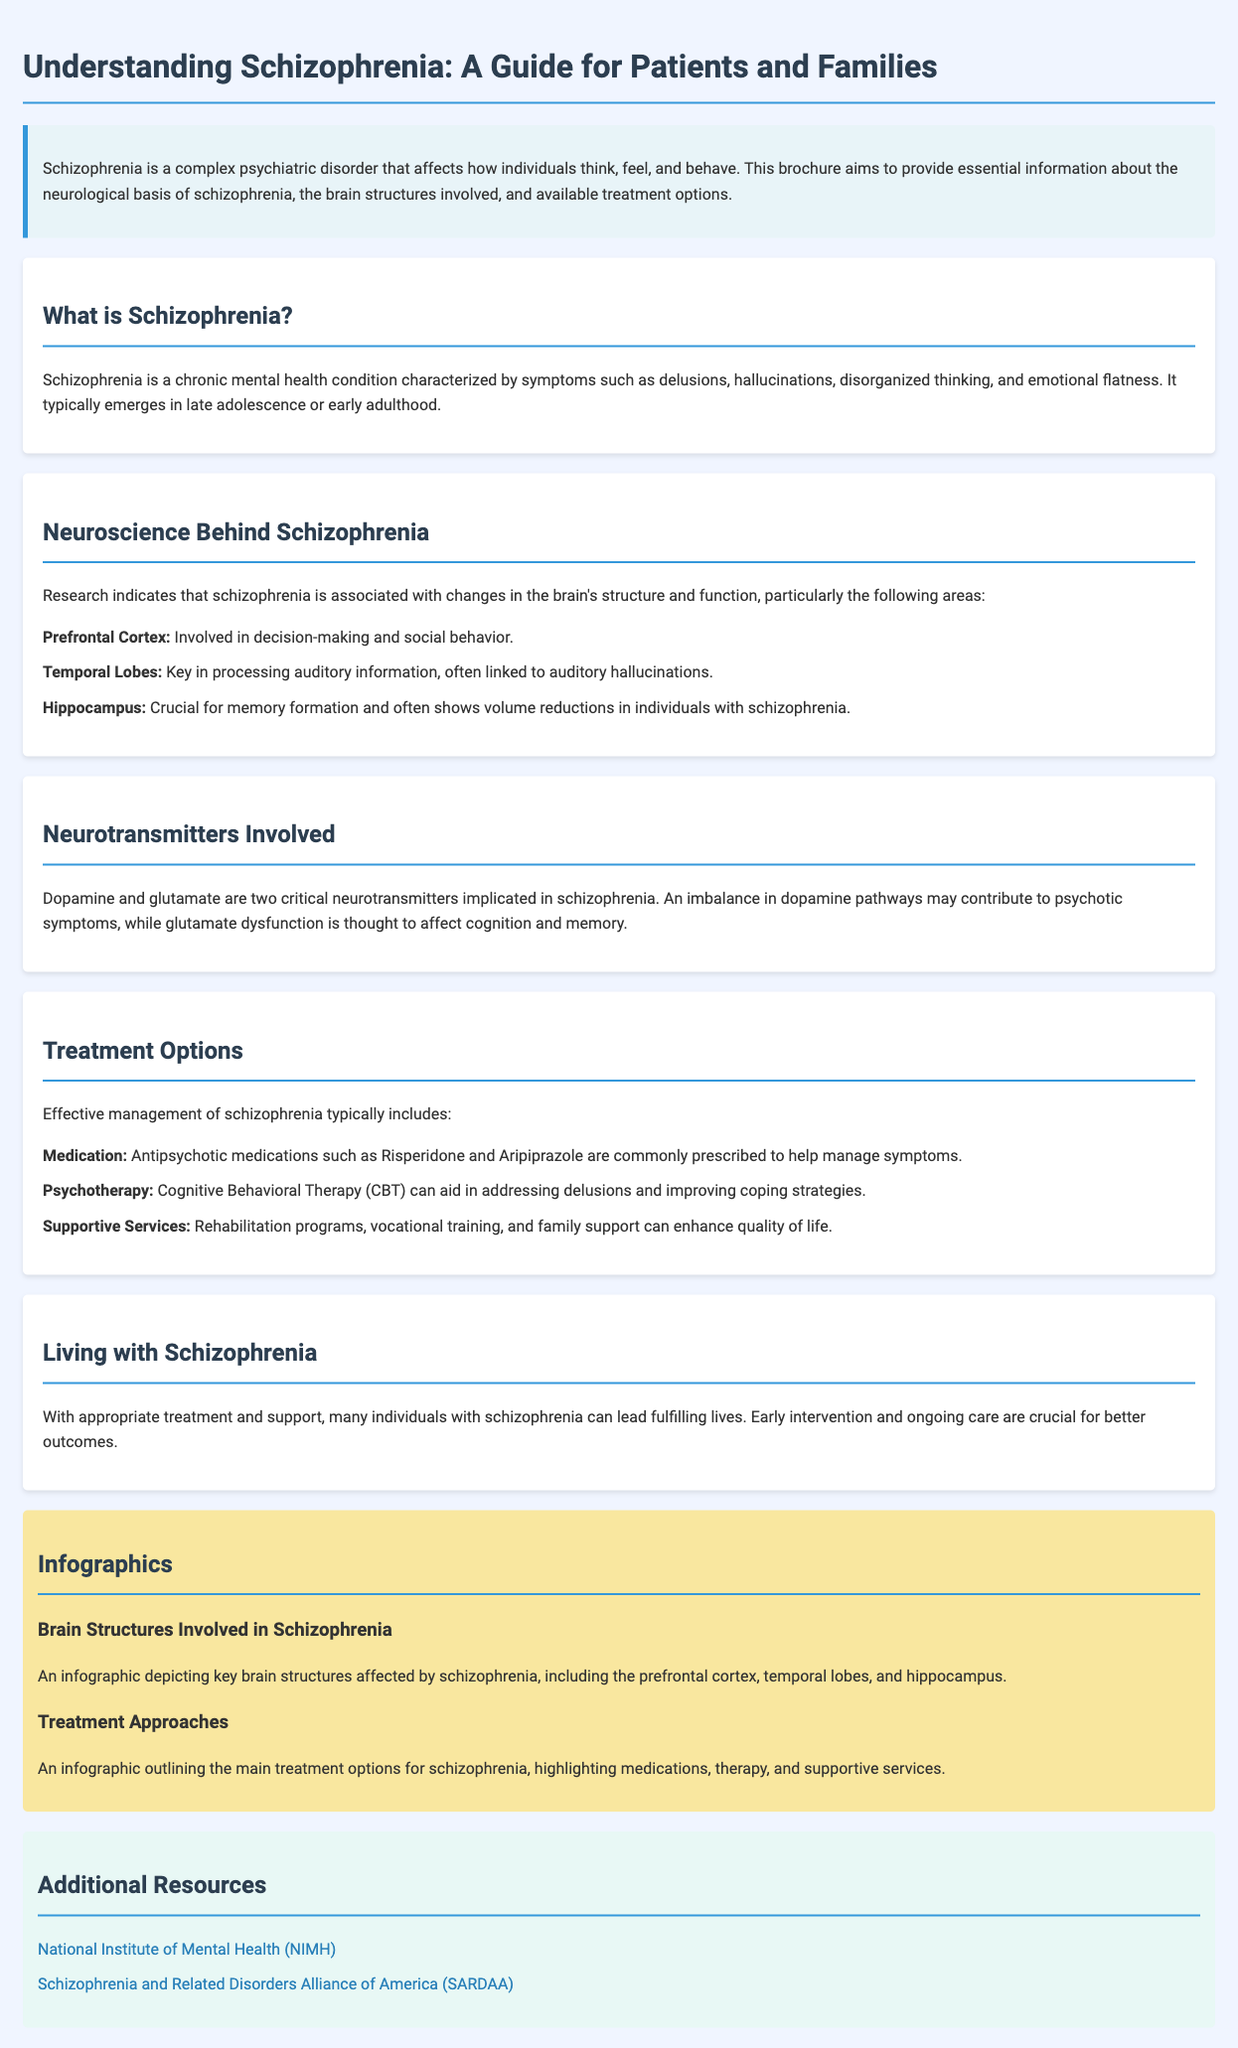What is the primary focus of the brochure? The brochure aims to provide essential information about the neurological basis of schizophrenia, the brain structures involved, and available treatment options.
Answer: neurological basis of schizophrenia Which brain structure is involved in decision-making? The document lists the prefrontal cortex as being involved in decision-making and social behavior.
Answer: Prefrontal Cortex What neurotransmitter imbalance may contribute to psychotic symptoms? The brochure indicates that an imbalance in dopamine pathways may contribute to psychotic symptoms.
Answer: dopamine What type of therapy is mentioned for addressing delusions? The document specifies Cognitive Behavioral Therapy (CBT) as a method for addressing delusions and improving coping strategies.
Answer: Cognitive Behavioral Therapy How many main treatment options are highlighted in the brochure? The brochure lists three main treatment options for managing schizophrenia: medication, psychotherapy, and supportive services.
Answer: three What is the significance of early intervention according to the document? The brochure emphasizes that early intervention and ongoing care are crucial for better outcomes for individuals living with schizophrenia.
Answer: better outcomes Which infographics are included in the brochure? The document includes infographics depicting key brain structures affected by schizophrenia and outlining the main treatment options.
Answer: Brain Structures and Treatment Approaches What type of resource does SARDAA provide? The document offers a link to the Schizophrenia and Related Disorders Alliance of America (SARDAA) for additional support and information.
Answer: support and information 